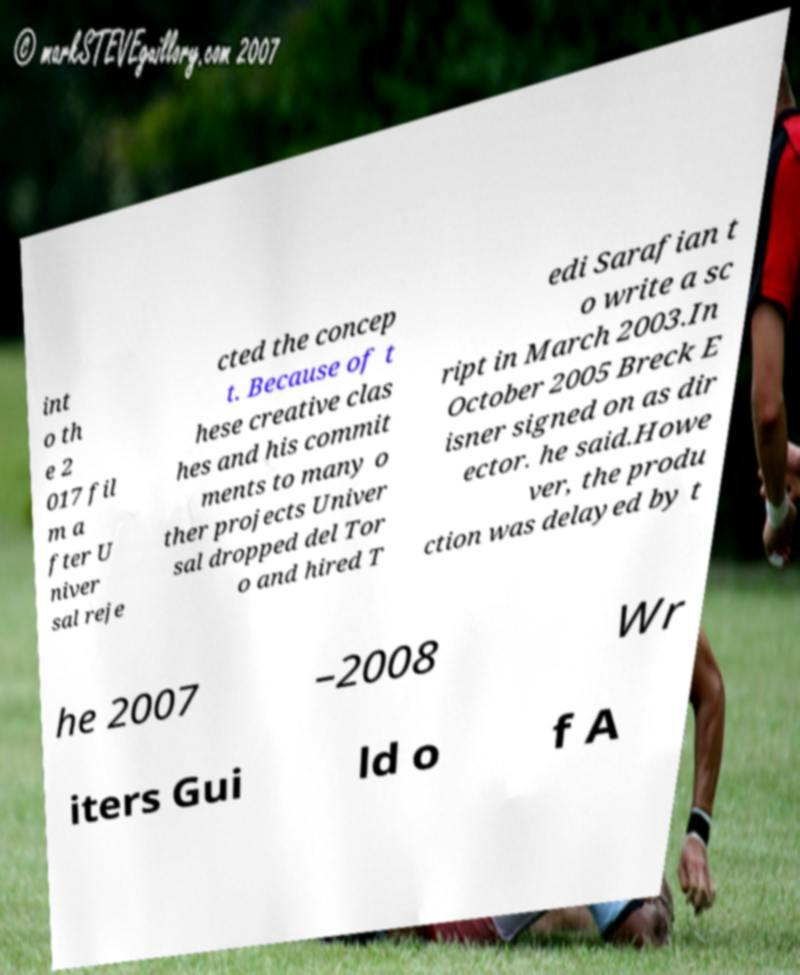Could you extract and type out the text from this image? int o th e 2 017 fil m a fter U niver sal reje cted the concep t. Because of t hese creative clas hes and his commit ments to many o ther projects Univer sal dropped del Tor o and hired T edi Sarafian t o write a sc ript in March 2003.In October 2005 Breck E isner signed on as dir ector. he said.Howe ver, the produ ction was delayed by t he 2007 –2008 Wr iters Gui ld o f A 